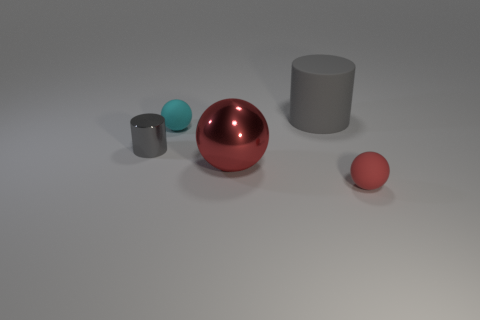What can you infer about the surface the objects are on? The surface appears to be smooth and even, with a very slight gradient in shading that hints at a slight curve, potentially to create a gentle drop-off for visual effect. It's reminiscent of a tabletop or platform used in product photography to ensure the focus stays on the objects. 